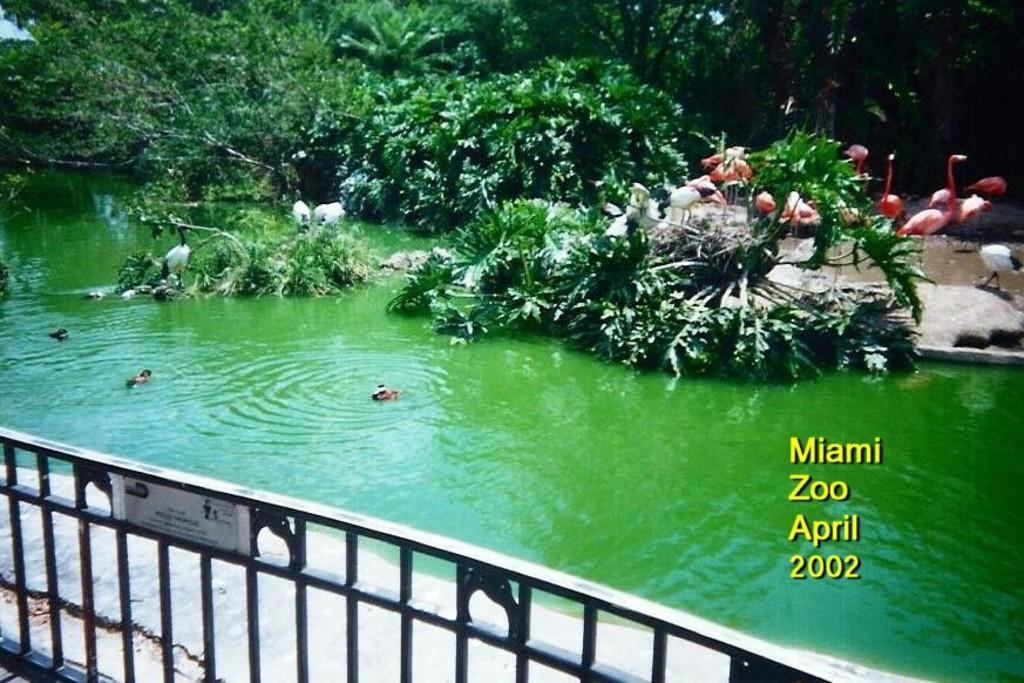Describe this image in one or two sentences. In this image there is one river in middle of this image. There are some trees in the background. There are some cranes in middle of this image and there is a text written at right side of this image and there is a boundary gate at bottom of this image. 